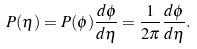<formula> <loc_0><loc_0><loc_500><loc_500>P ( \eta ) = P ( \phi ) \frac { d \phi } { d \eta } = \frac { 1 } { 2 \pi } \frac { d \phi } { d \eta } .</formula> 